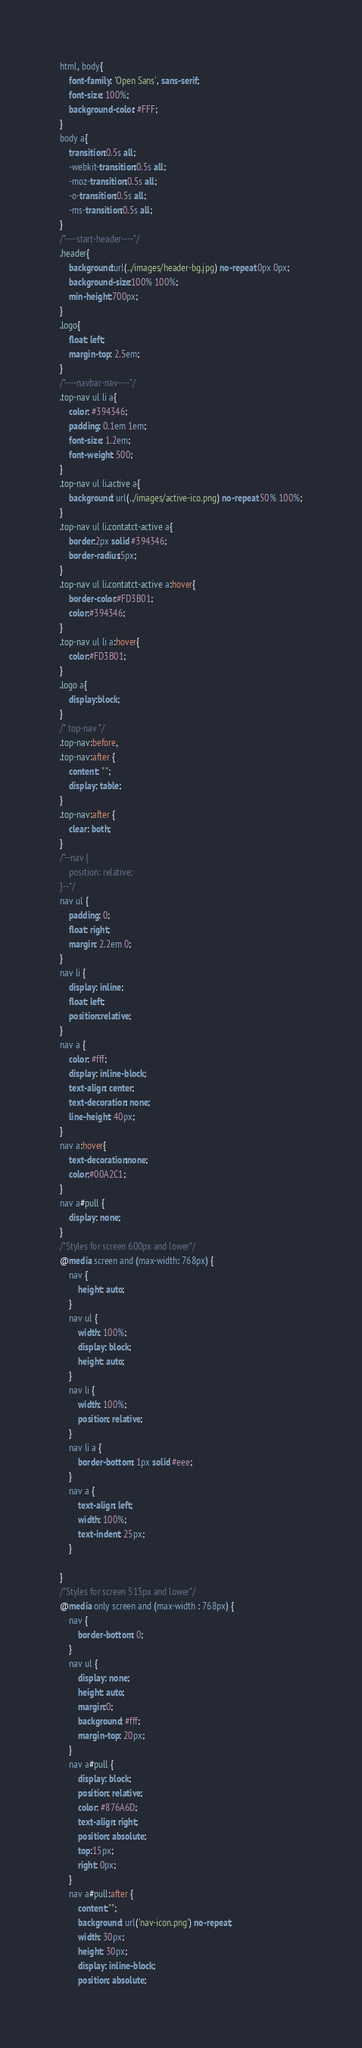<code> <loc_0><loc_0><loc_500><loc_500><_CSS_>html, body{
    font-family: 'Open Sans', sans-serif;
    font-size: 100%;
    background-color: #FFF;
}
body a{
	transition:0.5s all;
	-webkit-transition:0.5s all;
	-moz-transition:0.5s all;
	-o-transition:0.5s all;
	-ms-transition:0.5s all;
}
/*----start-header----*/
.header{
	background:url(../images/header-bg.jpg) no-repeat 0px 0px;
	background-size:100% 100%;
	min-height:700px;
}
.logo{
	float: left;
	margin-top: 2.5em;
}
/*----navbar-nav----*/
.top-nav ul li a{
	color: #394346;
	padding: 0.1em 1em;
	font-size: 1.2em;
	font-weight: 500;
}
.top-nav ul li.active a{
	background: url(../images/active-ico.png) no-repeat 50% 100%;
}
.top-nav ul li.contatct-active a{
	border:2px solid #394346;
	border-radius:5px;
}
.top-nav ul li.contatct-active a:hover{
	border-color:#FD3B01;
	color:#394346;
}
.top-nav ul li a:hover{
	color:#FD3B01;
}
.logo a{
	display:block;
}
/* top-nav */
.top-nav:before,
.top-nav:after {
    content: " ";
    display: table;
}
.top-nav:after {
    clear: both;
}
/*--nav {
	position: relative;
}--*/
nav ul {
	padding: 0;
	float: right;
	margin: 2.2em 0;
}
nav li {
	display: inline;
	float: left;
	position:relative;
}
nav a {
	color: #fff;
	display: inline-block;
	text-align: center;
	text-decoration: none;
	line-height: 40px;
}
nav a:hover{
	text-decoration:none;
	color:#00A2C1;
}
nav a#pull {
	display: none;
}
/*Styles for screen 600px and lower*/
@media screen and (max-width: 768px) {
	nav { 
  		height: auto;
  	}
  	nav ul {
  		width: 100%;
  		display: block;
  		height: auto;
  	}
  	nav li {
  		width: 100%;
  		position: relative;
  	}
  	nav li a {
		border-bottom: 1px solid #eee;
	}
  	nav a {
	  	text-align: left;
	  	width: 100%;
	  	text-indent: 25px;
  	}
  	
}
/*Styles for screen 515px and lower*/
@media only screen and (max-width : 768px) {
	nav {
		border-bottom: 0;
	}
	nav ul {
		display: none;
		height: auto;
		margin:0;
		background: #fff;
		margin-top: 20px;
	}
	nav a#pull {
		display: block;
		position: relative;
		color: #876A6D;
		text-align: right;
		position: absolute;
		top:15px;
		right: 0px;
	}
	nav a#pull:after {
		content:"";
		background: url('nav-icon.png') no-repeat;
		width: 30px;
		height: 30px;
		display: inline-block;
		position: absolute;</code> 